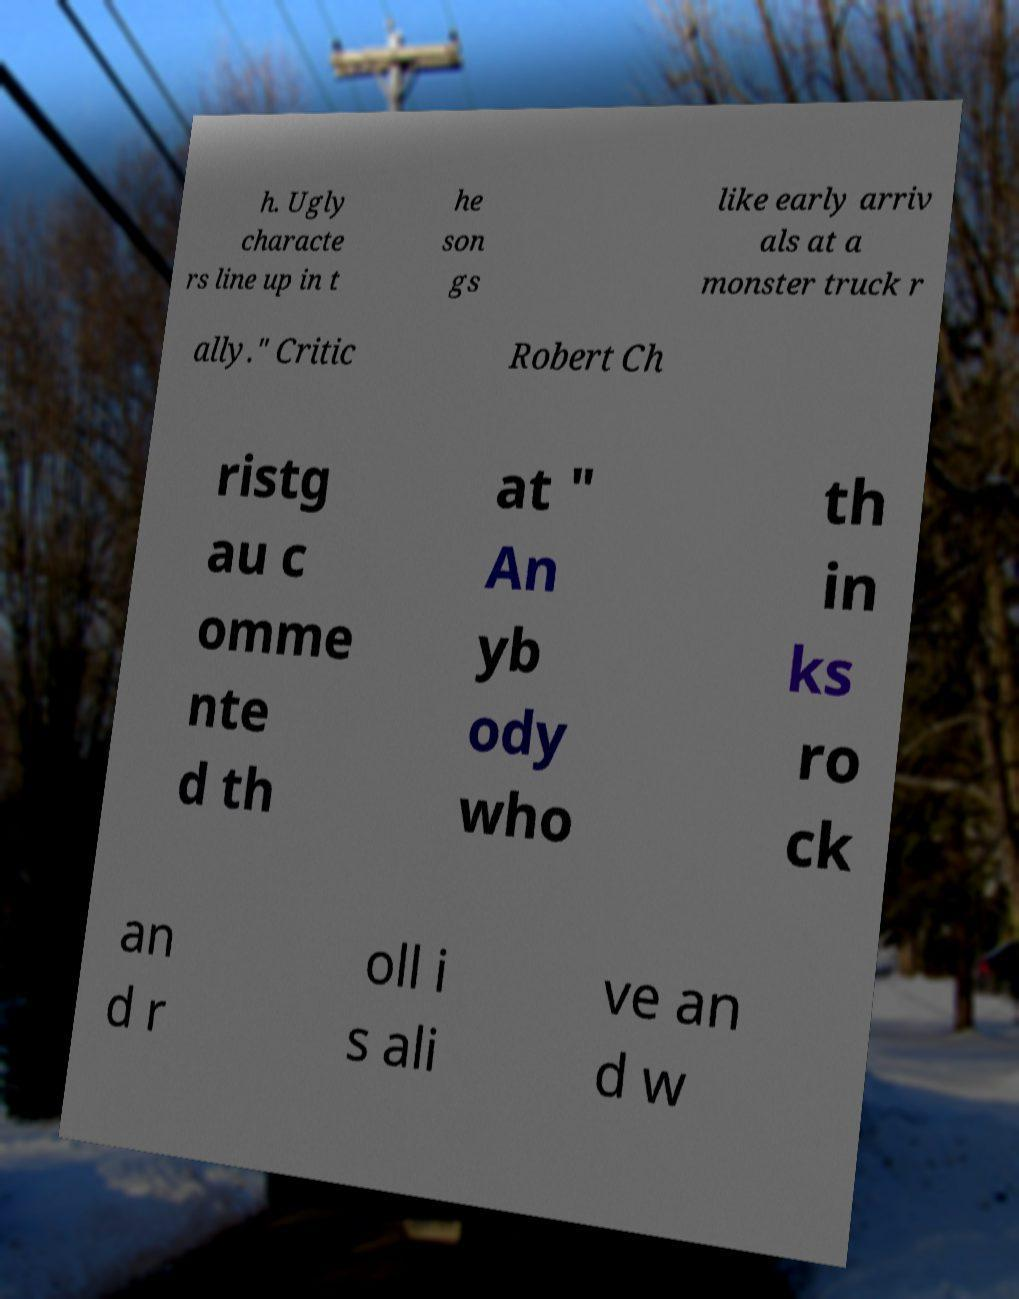Could you extract and type out the text from this image? h. Ugly characte rs line up in t he son gs like early arriv als at a monster truck r ally." Critic Robert Ch ristg au c omme nte d th at " An yb ody who th in ks ro ck an d r oll i s ali ve an d w 